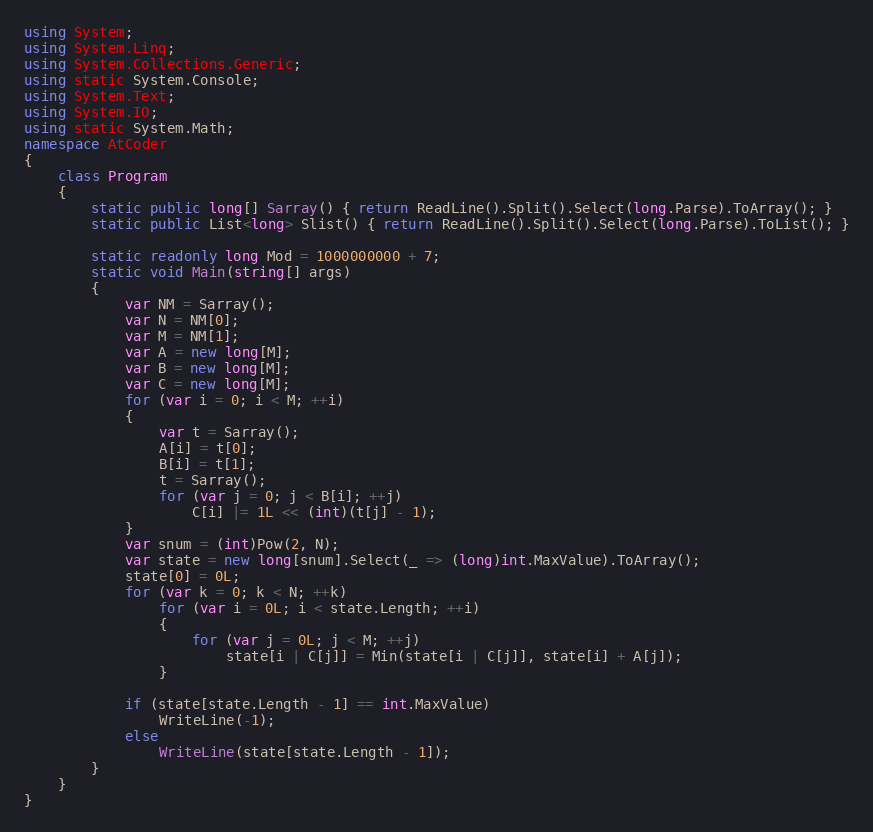<code> <loc_0><loc_0><loc_500><loc_500><_C#_>using System;
using System.Linq;
using System.Collections.Generic;
using static System.Console;
using System.Text;
using System.IO;
using static System.Math;
namespace AtCoder
{
    class Program
    {
        static public long[] Sarray() { return ReadLine().Split().Select(long.Parse).ToArray(); }
        static public List<long> Slist() { return ReadLine().Split().Select(long.Parse).ToList(); }

        static readonly long Mod = 1000000000 + 7;
        static void Main(string[] args)
        {
            var NM = Sarray();
            var N = NM[0];
            var M = NM[1];
            var A = new long[M];
            var B = new long[M];
            var C = new long[M];
            for (var i = 0; i < M; ++i)
            {
                var t = Sarray();
                A[i] = t[0];
                B[i] = t[1];
                t = Sarray();
                for (var j = 0; j < B[i]; ++j)
                    C[i] |= 1L << (int)(t[j] - 1);
            }
            var snum = (int)Pow(2, N);
            var state = new long[snum].Select(_ => (long)int.MaxValue).ToArray();
            state[0] = 0L;
            for (var k = 0; k < N; ++k)
                for (var i = 0L; i < state.Length; ++i)
                {
                    for (var j = 0L; j < M; ++j)
                        state[i | C[j]] = Min(state[i | C[j]], state[i] + A[j]);
                }

            if (state[state.Length - 1] == int.MaxValue)
                WriteLine(-1);
            else
                WriteLine(state[state.Length - 1]);
        }
    }
}</code> 